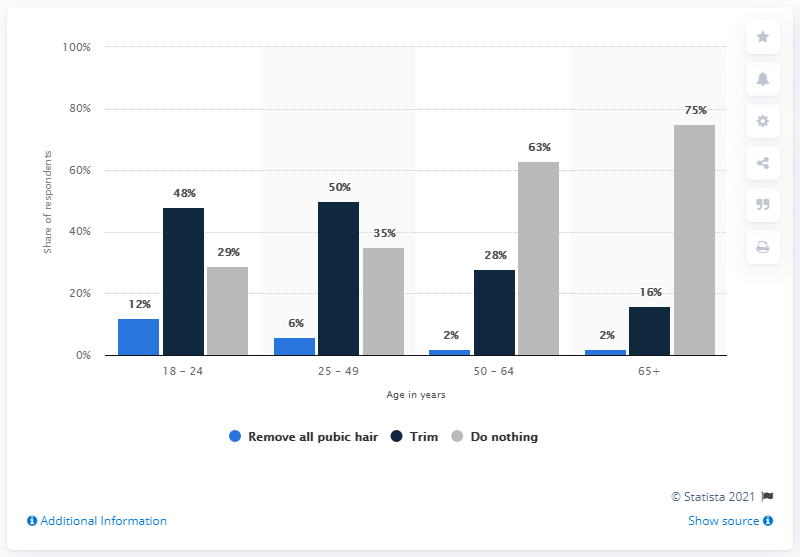Highlight a few significant elements in this photo. Six percent of males between the age of 25 and 49 expect to remove their pubic hair. In the age group of 65 and above, the difference between Trim and doing nothing is the maximum. 